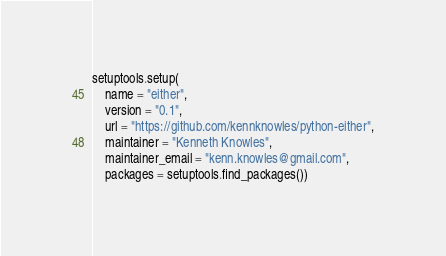<code> <loc_0><loc_0><loc_500><loc_500><_Python_>
setuptools.setup(   
    name = "either",
    version = "0.1",
    url = "https://github.com/kennknowles/python-either",
    maintainer = "Kenneth Knowles",
    maintainer_email = "kenn.knowles@gmail.com",
    packages = setuptools.find_packages())
</code> 